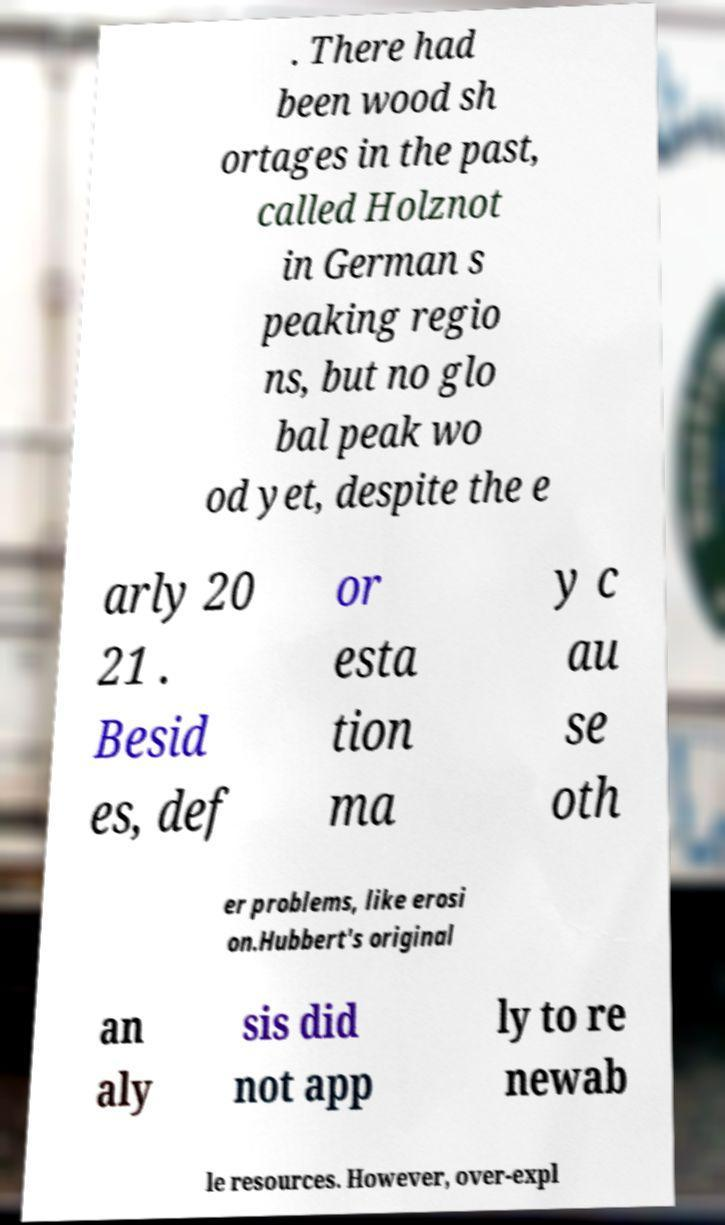Can you read and provide the text displayed in the image?This photo seems to have some interesting text. Can you extract and type it out for me? . There had been wood sh ortages in the past, called Holznot in German s peaking regio ns, but no glo bal peak wo od yet, despite the e arly 20 21 . Besid es, def or esta tion ma y c au se oth er problems, like erosi on.Hubbert's original an aly sis did not app ly to re newab le resources. However, over-expl 